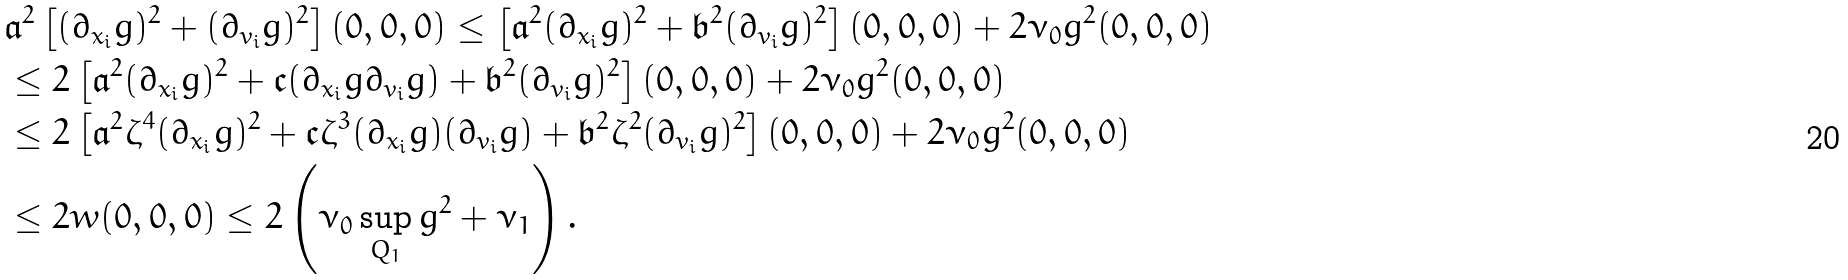Convert formula to latex. <formula><loc_0><loc_0><loc_500><loc_500>& \mathfrak a ^ { 2 } \left [ ( \partial _ { x _ { i } } g ) ^ { 2 } + ( \partial _ { v _ { i } } g ) ^ { 2 } \right ] ( 0 , 0 , 0 ) \leq \left [ \mathfrak a ^ { 2 } ( \partial _ { x _ { i } } g ) ^ { 2 } + \mathfrak b ^ { 2 } ( \partial _ { v _ { i } } g ) ^ { 2 } \right ] ( 0 , 0 , 0 ) + 2 \nu _ { 0 } g ^ { 2 } ( 0 , 0 , 0 ) \\ & \leq 2 \left [ \mathfrak a ^ { 2 } ( \partial _ { x _ { i } } g ) ^ { 2 } + \mathfrak c ( \partial _ { x _ { i } } g \partial _ { v _ { i } } g ) + \mathfrak b ^ { 2 } ( \partial _ { v _ { i } } g ) ^ { 2 } \right ] ( 0 , 0 , 0 ) + 2 \nu _ { 0 } g ^ { 2 } ( 0 , 0 , 0 ) \\ & \leq 2 \left [ \mathfrak a ^ { 2 } \zeta ^ { 4 } ( \partial _ { x _ { i } } g ) ^ { 2 } + \mathfrak c \zeta ^ { 3 } ( \partial _ { x _ { i } } g ) ( \partial _ { v _ { i } } g ) + \mathfrak b ^ { 2 } \zeta ^ { 2 } ( \partial _ { v _ { i } } g ) ^ { 2 } \right ] ( 0 , 0 , 0 ) + 2 \nu _ { 0 } g ^ { 2 } ( 0 , 0 , 0 ) \\ & \leq 2 w ( 0 , 0 , 0 ) \leq 2 \left ( \nu _ { 0 } \sup _ { Q _ { 1 } } g ^ { 2 } + \nu _ { 1 } \right ) .</formula> 